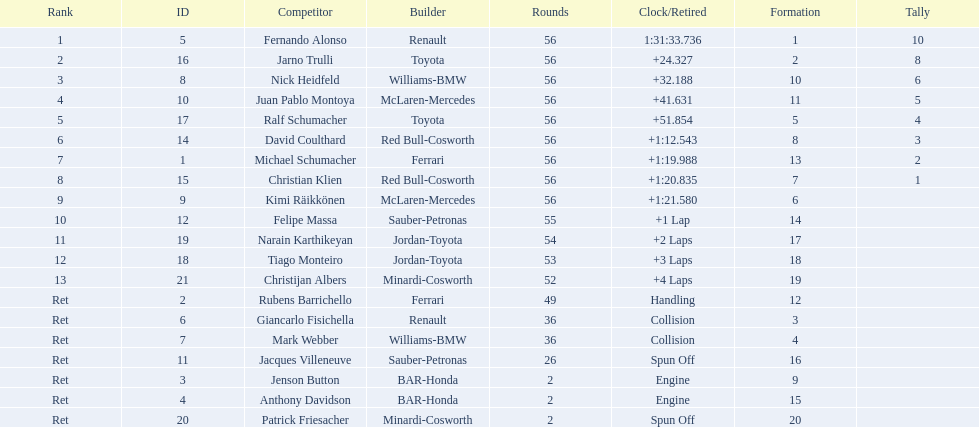Would you be able to parse every entry in this table? {'header': ['Rank', 'ID', 'Competitor', 'Builder', 'Rounds', 'Clock/Retired', 'Formation', 'Tally'], 'rows': [['1', '5', 'Fernando Alonso', 'Renault', '56', '1:31:33.736', '1', '10'], ['2', '16', 'Jarno Trulli', 'Toyota', '56', '+24.327', '2', '8'], ['3', '8', 'Nick Heidfeld', 'Williams-BMW', '56', '+32.188', '10', '6'], ['4', '10', 'Juan Pablo Montoya', 'McLaren-Mercedes', '56', '+41.631', '11', '5'], ['5', '17', 'Ralf Schumacher', 'Toyota', '56', '+51.854', '5', '4'], ['6', '14', 'David Coulthard', 'Red Bull-Cosworth', '56', '+1:12.543', '8', '3'], ['7', '1', 'Michael Schumacher', 'Ferrari', '56', '+1:19.988', '13', '2'], ['8', '15', 'Christian Klien', 'Red Bull-Cosworth', '56', '+1:20.835', '7', '1'], ['9', '9', 'Kimi Räikkönen', 'McLaren-Mercedes', '56', '+1:21.580', '6', ''], ['10', '12', 'Felipe Massa', 'Sauber-Petronas', '55', '+1 Lap', '14', ''], ['11', '19', 'Narain Karthikeyan', 'Jordan-Toyota', '54', '+2 Laps', '17', ''], ['12', '18', 'Tiago Monteiro', 'Jordan-Toyota', '53', '+3 Laps', '18', ''], ['13', '21', 'Christijan Albers', 'Minardi-Cosworth', '52', '+4 Laps', '19', ''], ['Ret', '2', 'Rubens Barrichello', 'Ferrari', '49', 'Handling', '12', ''], ['Ret', '6', 'Giancarlo Fisichella', 'Renault', '36', 'Collision', '3', ''], ['Ret', '7', 'Mark Webber', 'Williams-BMW', '36', 'Collision', '4', ''], ['Ret', '11', 'Jacques Villeneuve', 'Sauber-Petronas', '26', 'Spun Off', '16', ''], ['Ret', '3', 'Jenson Button', 'BAR-Honda', '2', 'Engine', '9', ''], ['Ret', '4', 'Anthony Davidson', 'BAR-Honda', '2', 'Engine', '15', ''], ['Ret', '20', 'Patrick Friesacher', 'Minardi-Cosworth', '2', 'Spun Off', '20', '']]} How many germans finished in the top five? 2. 